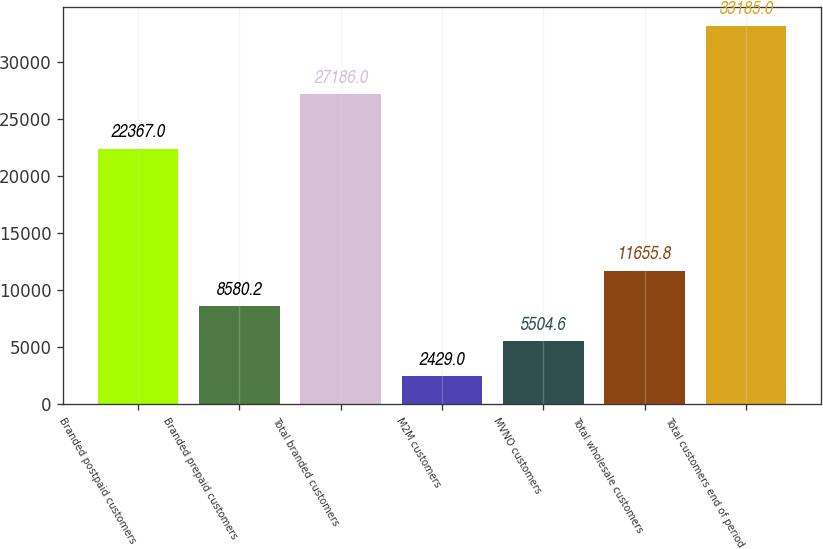Convert chart. <chart><loc_0><loc_0><loc_500><loc_500><bar_chart><fcel>Branded postpaid customers<fcel>Branded prepaid customers<fcel>Total branded customers<fcel>M2M customers<fcel>MVNO customers<fcel>Total wholesale customers<fcel>Total customers end of period<nl><fcel>22367<fcel>8580.2<fcel>27186<fcel>2429<fcel>5504.6<fcel>11655.8<fcel>33185<nl></chart> 